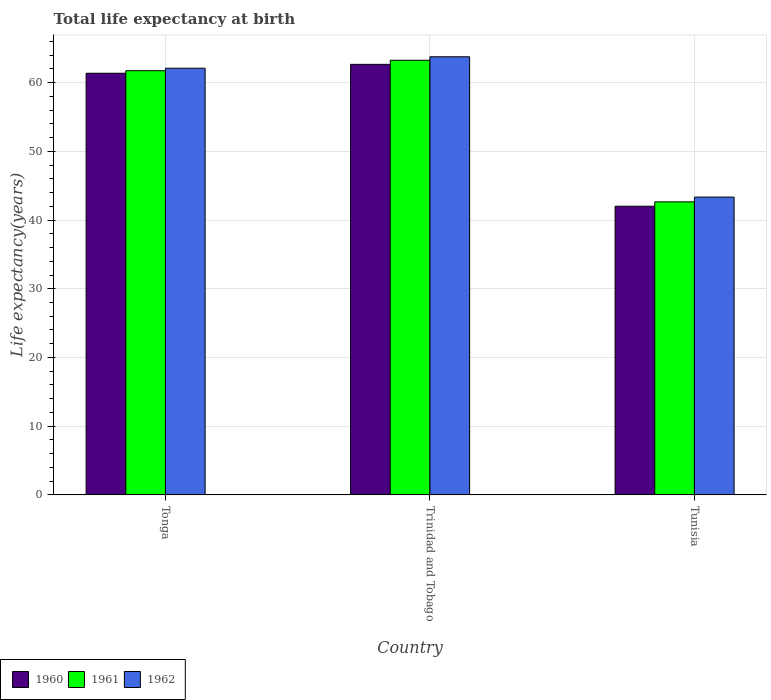How many groups of bars are there?
Ensure brevity in your answer.  3. Are the number of bars on each tick of the X-axis equal?
Ensure brevity in your answer.  Yes. How many bars are there on the 1st tick from the left?
Offer a very short reply. 3. What is the label of the 1st group of bars from the left?
Your response must be concise. Tonga. What is the life expectancy at birth in in 1960 in Trinidad and Tobago?
Provide a succinct answer. 62.66. Across all countries, what is the maximum life expectancy at birth in in 1960?
Your response must be concise. 62.66. Across all countries, what is the minimum life expectancy at birth in in 1961?
Give a very brief answer. 42.65. In which country was the life expectancy at birth in in 1960 maximum?
Make the answer very short. Trinidad and Tobago. In which country was the life expectancy at birth in in 1961 minimum?
Ensure brevity in your answer.  Tunisia. What is the total life expectancy at birth in in 1961 in the graph?
Offer a terse response. 167.63. What is the difference between the life expectancy at birth in in 1962 in Tonga and that in Tunisia?
Give a very brief answer. 18.76. What is the difference between the life expectancy at birth in in 1960 in Tunisia and the life expectancy at birth in in 1961 in Trinidad and Tobago?
Offer a very short reply. -21.24. What is the average life expectancy at birth in in 1962 per country?
Your response must be concise. 56.4. What is the difference between the life expectancy at birth in of/in 1962 and life expectancy at birth in of/in 1960 in Tunisia?
Keep it short and to the point. 1.33. In how many countries, is the life expectancy at birth in in 1962 greater than 8 years?
Offer a very short reply. 3. What is the ratio of the life expectancy at birth in in 1961 in Tonga to that in Trinidad and Tobago?
Keep it short and to the point. 0.98. Is the life expectancy at birth in in 1962 in Tonga less than that in Tunisia?
Provide a short and direct response. No. Is the difference between the life expectancy at birth in in 1962 in Tonga and Tunisia greater than the difference between the life expectancy at birth in in 1960 in Tonga and Tunisia?
Offer a very short reply. No. What is the difference between the highest and the second highest life expectancy at birth in in 1960?
Your response must be concise. -19.35. What is the difference between the highest and the lowest life expectancy at birth in in 1960?
Provide a short and direct response. 20.65. In how many countries, is the life expectancy at birth in in 1962 greater than the average life expectancy at birth in in 1962 taken over all countries?
Your answer should be very brief. 2. How many countries are there in the graph?
Your answer should be very brief. 3. What is the difference between two consecutive major ticks on the Y-axis?
Provide a short and direct response. 10. Does the graph contain any zero values?
Your response must be concise. No. Does the graph contain grids?
Your answer should be compact. Yes. Where does the legend appear in the graph?
Give a very brief answer. Bottom left. How are the legend labels stacked?
Your answer should be very brief. Horizontal. What is the title of the graph?
Keep it short and to the point. Total life expectancy at birth. Does "1968" appear as one of the legend labels in the graph?
Ensure brevity in your answer.  No. What is the label or title of the Y-axis?
Your response must be concise. Life expectancy(years). What is the Life expectancy(years) of 1960 in Tonga?
Provide a short and direct response. 61.36. What is the Life expectancy(years) of 1961 in Tonga?
Offer a very short reply. 61.73. What is the Life expectancy(years) of 1962 in Tonga?
Ensure brevity in your answer.  62.1. What is the Life expectancy(years) in 1960 in Trinidad and Tobago?
Your answer should be very brief. 62.66. What is the Life expectancy(years) in 1961 in Trinidad and Tobago?
Your answer should be very brief. 63.25. What is the Life expectancy(years) of 1962 in Trinidad and Tobago?
Your response must be concise. 63.76. What is the Life expectancy(years) of 1960 in Tunisia?
Keep it short and to the point. 42.01. What is the Life expectancy(years) of 1961 in Tunisia?
Your response must be concise. 42.65. What is the Life expectancy(years) in 1962 in Tunisia?
Make the answer very short. 43.34. Across all countries, what is the maximum Life expectancy(years) of 1960?
Provide a succinct answer. 62.66. Across all countries, what is the maximum Life expectancy(years) of 1961?
Your answer should be compact. 63.25. Across all countries, what is the maximum Life expectancy(years) in 1962?
Provide a short and direct response. 63.76. Across all countries, what is the minimum Life expectancy(years) of 1960?
Offer a terse response. 42.01. Across all countries, what is the minimum Life expectancy(years) in 1961?
Offer a terse response. 42.65. Across all countries, what is the minimum Life expectancy(years) in 1962?
Provide a short and direct response. 43.34. What is the total Life expectancy(years) of 1960 in the graph?
Offer a very short reply. 166.03. What is the total Life expectancy(years) of 1961 in the graph?
Provide a succinct answer. 167.63. What is the total Life expectancy(years) of 1962 in the graph?
Give a very brief answer. 169.2. What is the difference between the Life expectancy(years) of 1960 in Tonga and that in Trinidad and Tobago?
Your response must be concise. -1.29. What is the difference between the Life expectancy(years) in 1961 in Tonga and that in Trinidad and Tobago?
Offer a very short reply. -1.52. What is the difference between the Life expectancy(years) of 1962 in Tonga and that in Trinidad and Tobago?
Make the answer very short. -1.66. What is the difference between the Life expectancy(years) of 1960 in Tonga and that in Tunisia?
Provide a short and direct response. 19.35. What is the difference between the Life expectancy(years) in 1961 in Tonga and that in Tunisia?
Offer a very short reply. 19.09. What is the difference between the Life expectancy(years) of 1962 in Tonga and that in Tunisia?
Give a very brief answer. 18.76. What is the difference between the Life expectancy(years) in 1960 in Trinidad and Tobago and that in Tunisia?
Provide a short and direct response. 20.65. What is the difference between the Life expectancy(years) of 1961 in Trinidad and Tobago and that in Tunisia?
Provide a short and direct response. 20.61. What is the difference between the Life expectancy(years) of 1962 in Trinidad and Tobago and that in Tunisia?
Ensure brevity in your answer.  20.42. What is the difference between the Life expectancy(years) of 1960 in Tonga and the Life expectancy(years) of 1961 in Trinidad and Tobago?
Provide a succinct answer. -1.89. What is the difference between the Life expectancy(years) of 1960 in Tonga and the Life expectancy(years) of 1962 in Trinidad and Tobago?
Keep it short and to the point. -2.4. What is the difference between the Life expectancy(years) of 1961 in Tonga and the Life expectancy(years) of 1962 in Trinidad and Tobago?
Your response must be concise. -2.03. What is the difference between the Life expectancy(years) in 1960 in Tonga and the Life expectancy(years) in 1961 in Tunisia?
Give a very brief answer. 18.72. What is the difference between the Life expectancy(years) in 1960 in Tonga and the Life expectancy(years) in 1962 in Tunisia?
Your response must be concise. 18.02. What is the difference between the Life expectancy(years) of 1961 in Tonga and the Life expectancy(years) of 1962 in Tunisia?
Your answer should be very brief. 18.39. What is the difference between the Life expectancy(years) of 1960 in Trinidad and Tobago and the Life expectancy(years) of 1961 in Tunisia?
Keep it short and to the point. 20.01. What is the difference between the Life expectancy(years) in 1960 in Trinidad and Tobago and the Life expectancy(years) in 1962 in Tunisia?
Your response must be concise. 19.32. What is the difference between the Life expectancy(years) in 1961 in Trinidad and Tobago and the Life expectancy(years) in 1962 in Tunisia?
Make the answer very short. 19.91. What is the average Life expectancy(years) in 1960 per country?
Your answer should be very brief. 55.34. What is the average Life expectancy(years) in 1961 per country?
Provide a short and direct response. 55.88. What is the average Life expectancy(years) in 1962 per country?
Provide a short and direct response. 56.4. What is the difference between the Life expectancy(years) of 1960 and Life expectancy(years) of 1961 in Tonga?
Your answer should be very brief. -0.37. What is the difference between the Life expectancy(years) in 1960 and Life expectancy(years) in 1962 in Tonga?
Your answer should be very brief. -0.73. What is the difference between the Life expectancy(years) in 1961 and Life expectancy(years) in 1962 in Tonga?
Offer a very short reply. -0.36. What is the difference between the Life expectancy(years) of 1960 and Life expectancy(years) of 1961 in Trinidad and Tobago?
Make the answer very short. -0.6. What is the difference between the Life expectancy(years) of 1960 and Life expectancy(years) of 1962 in Trinidad and Tobago?
Ensure brevity in your answer.  -1.1. What is the difference between the Life expectancy(years) in 1961 and Life expectancy(years) in 1962 in Trinidad and Tobago?
Offer a very short reply. -0.51. What is the difference between the Life expectancy(years) of 1960 and Life expectancy(years) of 1961 in Tunisia?
Offer a very short reply. -0.64. What is the difference between the Life expectancy(years) of 1960 and Life expectancy(years) of 1962 in Tunisia?
Keep it short and to the point. -1.33. What is the difference between the Life expectancy(years) of 1961 and Life expectancy(years) of 1962 in Tunisia?
Offer a very short reply. -0.7. What is the ratio of the Life expectancy(years) of 1960 in Tonga to that in Trinidad and Tobago?
Give a very brief answer. 0.98. What is the ratio of the Life expectancy(years) of 1961 in Tonga to that in Trinidad and Tobago?
Offer a terse response. 0.98. What is the ratio of the Life expectancy(years) of 1962 in Tonga to that in Trinidad and Tobago?
Your answer should be compact. 0.97. What is the ratio of the Life expectancy(years) of 1960 in Tonga to that in Tunisia?
Give a very brief answer. 1.46. What is the ratio of the Life expectancy(years) in 1961 in Tonga to that in Tunisia?
Your response must be concise. 1.45. What is the ratio of the Life expectancy(years) in 1962 in Tonga to that in Tunisia?
Your answer should be very brief. 1.43. What is the ratio of the Life expectancy(years) of 1960 in Trinidad and Tobago to that in Tunisia?
Provide a succinct answer. 1.49. What is the ratio of the Life expectancy(years) in 1961 in Trinidad and Tobago to that in Tunisia?
Ensure brevity in your answer.  1.48. What is the ratio of the Life expectancy(years) of 1962 in Trinidad and Tobago to that in Tunisia?
Provide a short and direct response. 1.47. What is the difference between the highest and the second highest Life expectancy(years) in 1960?
Provide a succinct answer. 1.29. What is the difference between the highest and the second highest Life expectancy(years) in 1961?
Provide a short and direct response. 1.52. What is the difference between the highest and the second highest Life expectancy(years) in 1962?
Give a very brief answer. 1.66. What is the difference between the highest and the lowest Life expectancy(years) in 1960?
Your answer should be very brief. 20.65. What is the difference between the highest and the lowest Life expectancy(years) of 1961?
Your response must be concise. 20.61. What is the difference between the highest and the lowest Life expectancy(years) of 1962?
Keep it short and to the point. 20.42. 